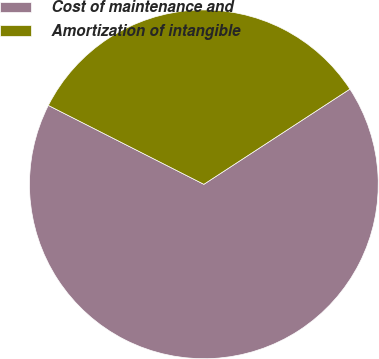<chart> <loc_0><loc_0><loc_500><loc_500><pie_chart><fcel>Cost of maintenance and<fcel>Amortization of intangible<nl><fcel>66.67%<fcel>33.33%<nl></chart> 